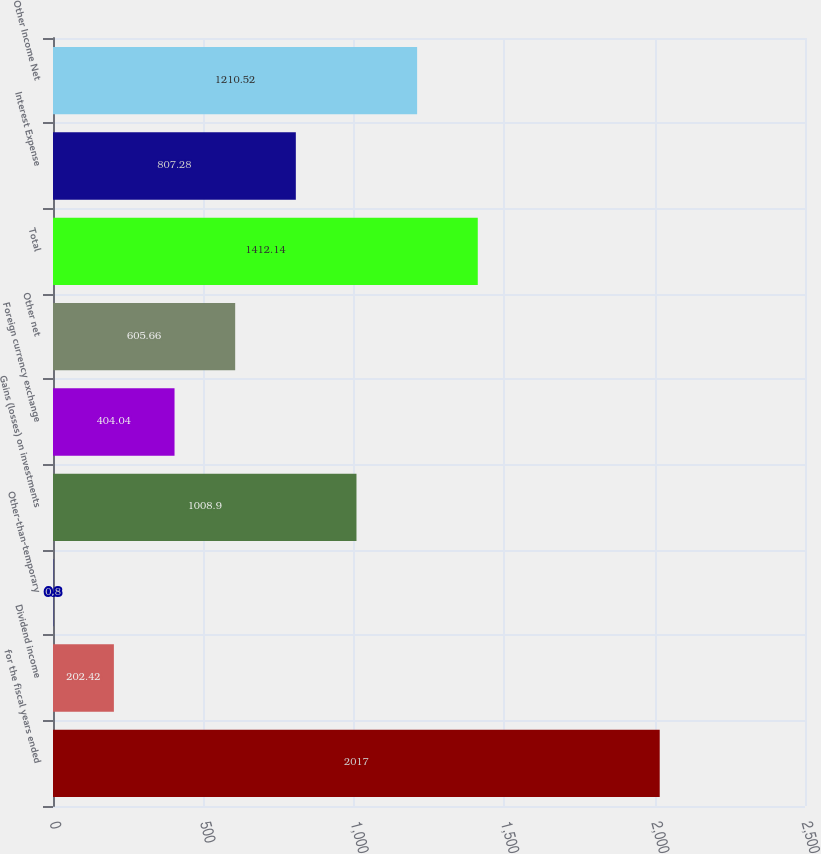<chart> <loc_0><loc_0><loc_500><loc_500><bar_chart><fcel>for the fiscal years ended<fcel>Dividend income<fcel>Other-than-temporary<fcel>Gains (losses) on investments<fcel>Foreign currency exchange<fcel>Other net<fcel>Total<fcel>Interest Expense<fcel>Other Income Net<nl><fcel>2017<fcel>202.42<fcel>0.8<fcel>1008.9<fcel>404.04<fcel>605.66<fcel>1412.14<fcel>807.28<fcel>1210.52<nl></chart> 